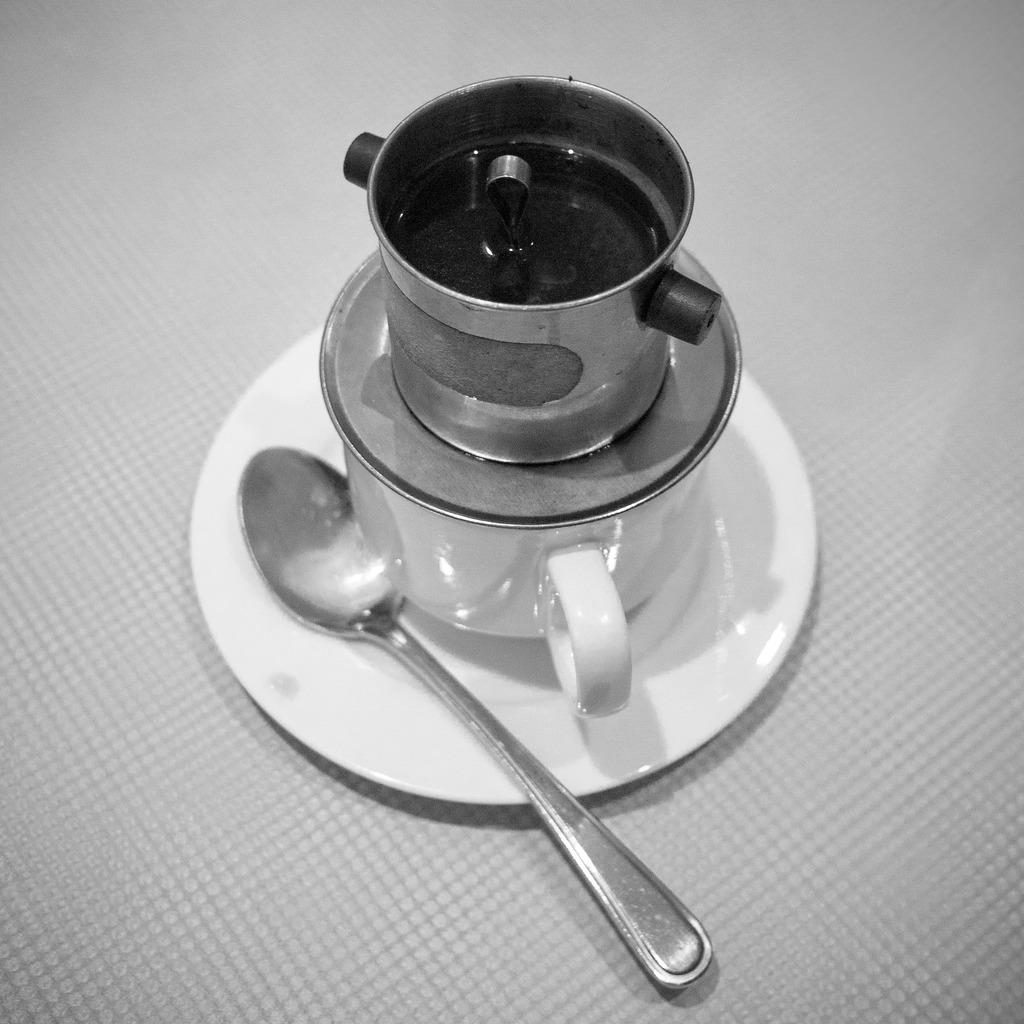What is the main object on the table in the image? There is a bowl on a cup in the image. What is the cup resting on? The cup is on a saucer. What utensil is present in the image? There is a spoon in the image. Where are these objects located? The objects are on a table. How is the image presented? The image is in black and white mode. What type of clam is sitting on the stage in the image? There is no clam or stage present in the image; it features a bowl on a cup, a saucer, and a spoon on a table. 